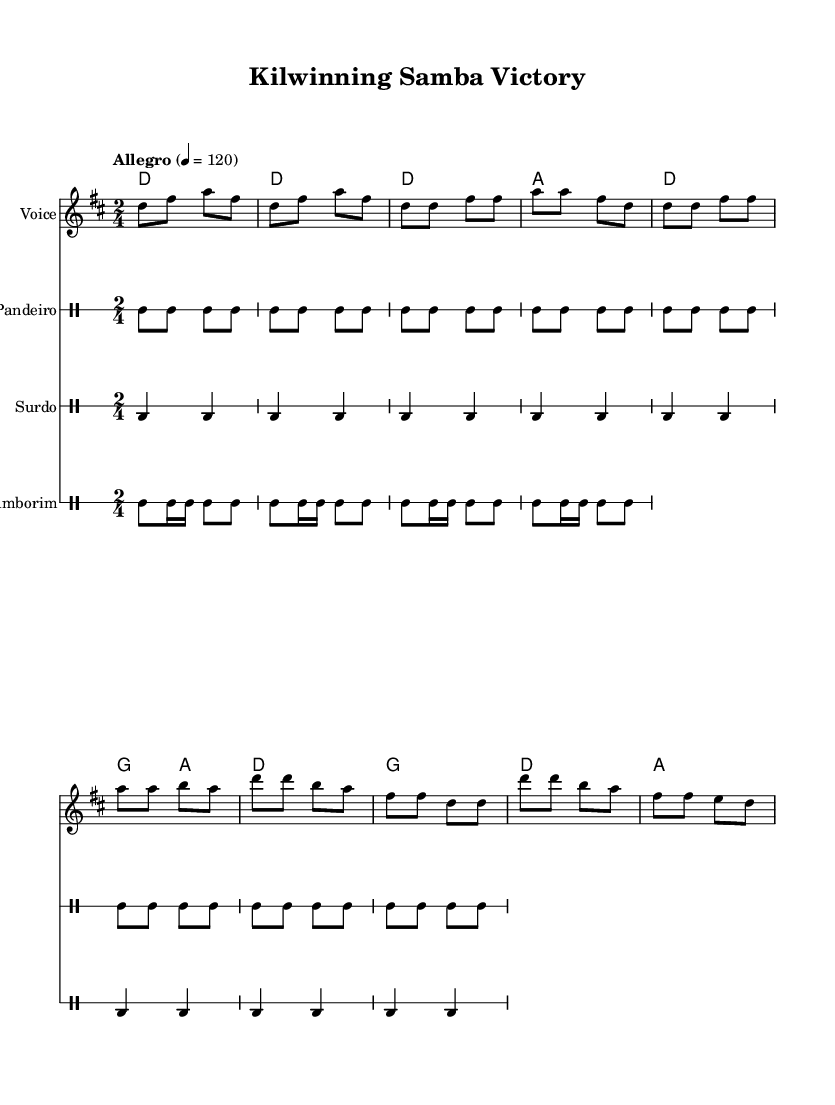What is the key signature of this music? The key signature indicated at the beginning of the sheet music is D major, which is represented by the key signature containing two sharps (F# and C#).
Answer: D major What is the time signature of the piece? The time signature displayed on the sheet music is 2/4, meaning there are two beats in a measure and a quarter note receives one beat.
Answer: 2/4 What is the tempo marking for this piece? The tempo marking shows "Allegro", which indicates a fast and lively pace, usually around 120 beats per minute.
Answer: Allegro What is the first instrument shown in the score? The first instrument listed is "Voice", which refers to the melody part for vocals.
Answer: Voice How many measures are in the verse section? By counting the measures in the verse segment, there are 4 measures specified, consisting of repeated musical patterns for the singing section.
Answer: 4 measures What type of percussion instruments are featured in this composition? The percussion instruments included are Pandeiro, Surdo, and Tamborim, each contributing to the rhythmic structure typical of samba music.
Answer: Pandeiro, Surdo, Tamborim What is the primary lyrical theme of the chorus? The lyrics in the chorus celebrate victory and the joyful spirit of Kilwinning Rangers, reflecting a festive post-match celebration.
Answer: Celebration of victory 